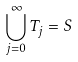Convert formula to latex. <formula><loc_0><loc_0><loc_500><loc_500>\bigcup _ { j = 0 } ^ { \infty } T _ { j } = S</formula> 